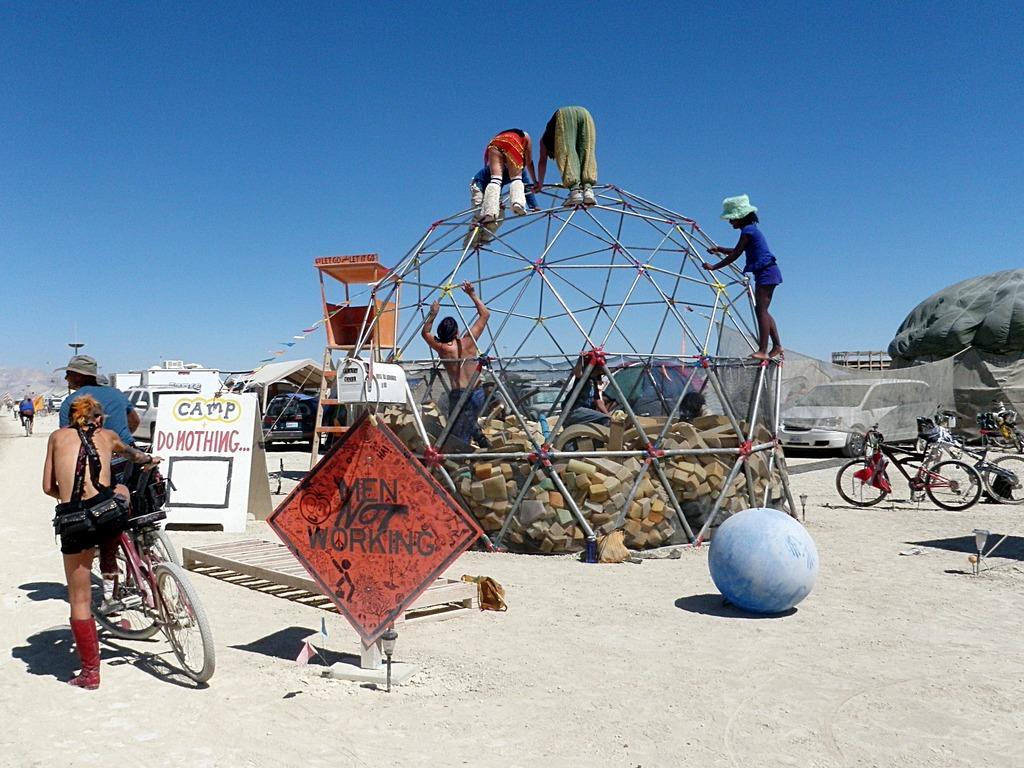Please provide a concise description of this image. In this image, In the left side there is a man holding a bicycle, There is a red color poster, In the middle there are some people climbing on the ball made of rods, There is a blue color ball, In the right side there are some bicycles and there is a white color car, In the background there is a blue color sky. 